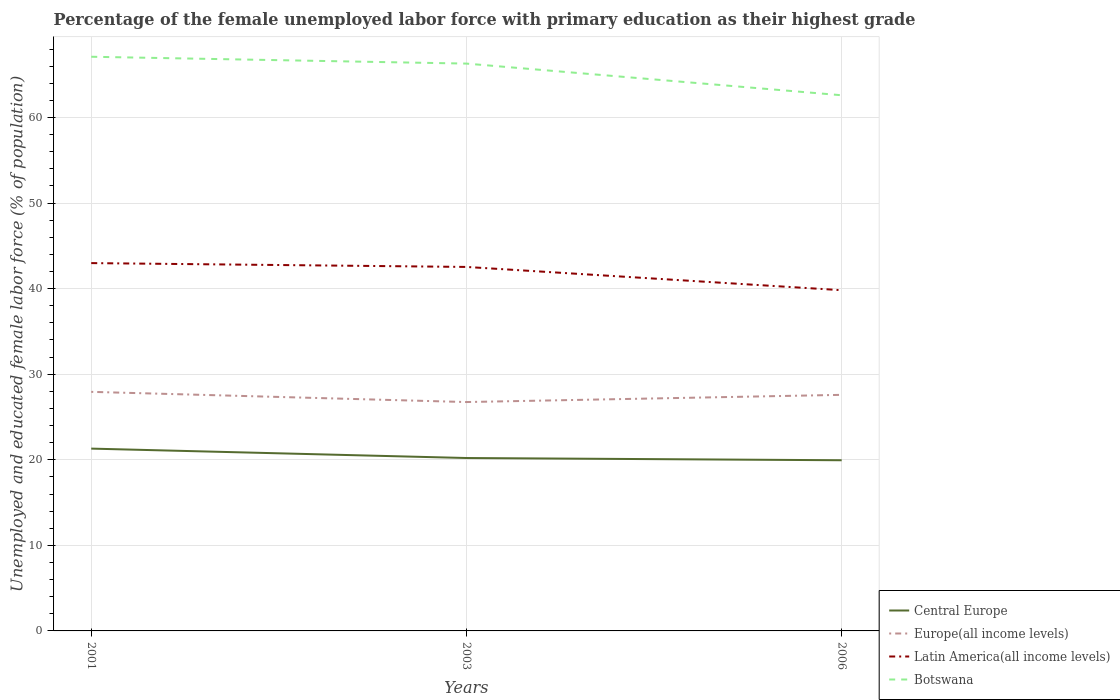Across all years, what is the maximum percentage of the unemployed female labor force with primary education in Botswana?
Your answer should be compact. 62.6. In which year was the percentage of the unemployed female labor force with primary education in Latin America(all income levels) maximum?
Make the answer very short. 2006. What is the total percentage of the unemployed female labor force with primary education in Latin America(all income levels) in the graph?
Your answer should be very brief. 0.45. What is the difference between the highest and the second highest percentage of the unemployed female labor force with primary education in Latin America(all income levels)?
Give a very brief answer. 3.17. What is the difference between the highest and the lowest percentage of the unemployed female labor force with primary education in Latin America(all income levels)?
Make the answer very short. 2. Is the percentage of the unemployed female labor force with primary education in Botswana strictly greater than the percentage of the unemployed female labor force with primary education in Latin America(all income levels) over the years?
Your answer should be very brief. No. How many lines are there?
Provide a short and direct response. 4. Does the graph contain any zero values?
Keep it short and to the point. No. Does the graph contain grids?
Your response must be concise. Yes. What is the title of the graph?
Ensure brevity in your answer.  Percentage of the female unemployed labor force with primary education as their highest grade. What is the label or title of the Y-axis?
Your answer should be very brief. Unemployed and educated female labor force (% of population). What is the Unemployed and educated female labor force (% of population) in Central Europe in 2001?
Offer a terse response. 21.31. What is the Unemployed and educated female labor force (% of population) of Europe(all income levels) in 2001?
Give a very brief answer. 27.94. What is the Unemployed and educated female labor force (% of population) of Latin America(all income levels) in 2001?
Ensure brevity in your answer.  42.99. What is the Unemployed and educated female labor force (% of population) of Botswana in 2001?
Keep it short and to the point. 67.1. What is the Unemployed and educated female labor force (% of population) in Central Europe in 2003?
Make the answer very short. 20.21. What is the Unemployed and educated female labor force (% of population) in Europe(all income levels) in 2003?
Offer a terse response. 26.75. What is the Unemployed and educated female labor force (% of population) in Latin America(all income levels) in 2003?
Offer a very short reply. 42.54. What is the Unemployed and educated female labor force (% of population) of Botswana in 2003?
Provide a succinct answer. 66.3. What is the Unemployed and educated female labor force (% of population) of Central Europe in 2006?
Keep it short and to the point. 19.95. What is the Unemployed and educated female labor force (% of population) in Europe(all income levels) in 2006?
Ensure brevity in your answer.  27.59. What is the Unemployed and educated female labor force (% of population) in Latin America(all income levels) in 2006?
Your answer should be very brief. 39.82. What is the Unemployed and educated female labor force (% of population) of Botswana in 2006?
Your answer should be very brief. 62.6. Across all years, what is the maximum Unemployed and educated female labor force (% of population) in Central Europe?
Your answer should be compact. 21.31. Across all years, what is the maximum Unemployed and educated female labor force (% of population) of Europe(all income levels)?
Your response must be concise. 27.94. Across all years, what is the maximum Unemployed and educated female labor force (% of population) in Latin America(all income levels)?
Give a very brief answer. 42.99. Across all years, what is the maximum Unemployed and educated female labor force (% of population) in Botswana?
Give a very brief answer. 67.1. Across all years, what is the minimum Unemployed and educated female labor force (% of population) in Central Europe?
Your answer should be compact. 19.95. Across all years, what is the minimum Unemployed and educated female labor force (% of population) in Europe(all income levels)?
Your answer should be compact. 26.75. Across all years, what is the minimum Unemployed and educated female labor force (% of population) of Latin America(all income levels)?
Your answer should be very brief. 39.82. Across all years, what is the minimum Unemployed and educated female labor force (% of population) of Botswana?
Provide a succinct answer. 62.6. What is the total Unemployed and educated female labor force (% of population) in Central Europe in the graph?
Make the answer very short. 61.46. What is the total Unemployed and educated female labor force (% of population) of Europe(all income levels) in the graph?
Ensure brevity in your answer.  82.27. What is the total Unemployed and educated female labor force (% of population) of Latin America(all income levels) in the graph?
Give a very brief answer. 125.34. What is the total Unemployed and educated female labor force (% of population) of Botswana in the graph?
Your answer should be compact. 196. What is the difference between the Unemployed and educated female labor force (% of population) of Europe(all income levels) in 2001 and that in 2003?
Provide a short and direct response. 1.19. What is the difference between the Unemployed and educated female labor force (% of population) in Latin America(all income levels) in 2001 and that in 2003?
Provide a short and direct response. 0.45. What is the difference between the Unemployed and educated female labor force (% of population) in Botswana in 2001 and that in 2003?
Offer a very short reply. 0.8. What is the difference between the Unemployed and educated female labor force (% of population) of Central Europe in 2001 and that in 2006?
Your answer should be very brief. 1.36. What is the difference between the Unemployed and educated female labor force (% of population) in Europe(all income levels) in 2001 and that in 2006?
Your answer should be compact. 0.35. What is the difference between the Unemployed and educated female labor force (% of population) of Latin America(all income levels) in 2001 and that in 2006?
Ensure brevity in your answer.  3.17. What is the difference between the Unemployed and educated female labor force (% of population) in Botswana in 2001 and that in 2006?
Ensure brevity in your answer.  4.5. What is the difference between the Unemployed and educated female labor force (% of population) of Central Europe in 2003 and that in 2006?
Your answer should be very brief. 0.26. What is the difference between the Unemployed and educated female labor force (% of population) of Europe(all income levels) in 2003 and that in 2006?
Offer a very short reply. -0.84. What is the difference between the Unemployed and educated female labor force (% of population) of Latin America(all income levels) in 2003 and that in 2006?
Offer a very short reply. 2.72. What is the difference between the Unemployed and educated female labor force (% of population) of Botswana in 2003 and that in 2006?
Ensure brevity in your answer.  3.7. What is the difference between the Unemployed and educated female labor force (% of population) of Central Europe in 2001 and the Unemployed and educated female labor force (% of population) of Europe(all income levels) in 2003?
Provide a succinct answer. -5.44. What is the difference between the Unemployed and educated female labor force (% of population) in Central Europe in 2001 and the Unemployed and educated female labor force (% of population) in Latin America(all income levels) in 2003?
Offer a very short reply. -21.23. What is the difference between the Unemployed and educated female labor force (% of population) of Central Europe in 2001 and the Unemployed and educated female labor force (% of population) of Botswana in 2003?
Your answer should be compact. -44.99. What is the difference between the Unemployed and educated female labor force (% of population) of Europe(all income levels) in 2001 and the Unemployed and educated female labor force (% of population) of Latin America(all income levels) in 2003?
Ensure brevity in your answer.  -14.6. What is the difference between the Unemployed and educated female labor force (% of population) of Europe(all income levels) in 2001 and the Unemployed and educated female labor force (% of population) of Botswana in 2003?
Provide a succinct answer. -38.36. What is the difference between the Unemployed and educated female labor force (% of population) in Latin America(all income levels) in 2001 and the Unemployed and educated female labor force (% of population) in Botswana in 2003?
Provide a succinct answer. -23.31. What is the difference between the Unemployed and educated female labor force (% of population) in Central Europe in 2001 and the Unemployed and educated female labor force (% of population) in Europe(all income levels) in 2006?
Offer a very short reply. -6.28. What is the difference between the Unemployed and educated female labor force (% of population) of Central Europe in 2001 and the Unemployed and educated female labor force (% of population) of Latin America(all income levels) in 2006?
Your response must be concise. -18.51. What is the difference between the Unemployed and educated female labor force (% of population) in Central Europe in 2001 and the Unemployed and educated female labor force (% of population) in Botswana in 2006?
Your response must be concise. -41.29. What is the difference between the Unemployed and educated female labor force (% of population) in Europe(all income levels) in 2001 and the Unemployed and educated female labor force (% of population) in Latin America(all income levels) in 2006?
Your answer should be compact. -11.88. What is the difference between the Unemployed and educated female labor force (% of population) in Europe(all income levels) in 2001 and the Unemployed and educated female labor force (% of population) in Botswana in 2006?
Make the answer very short. -34.66. What is the difference between the Unemployed and educated female labor force (% of population) of Latin America(all income levels) in 2001 and the Unemployed and educated female labor force (% of population) of Botswana in 2006?
Your answer should be compact. -19.61. What is the difference between the Unemployed and educated female labor force (% of population) in Central Europe in 2003 and the Unemployed and educated female labor force (% of population) in Europe(all income levels) in 2006?
Make the answer very short. -7.38. What is the difference between the Unemployed and educated female labor force (% of population) of Central Europe in 2003 and the Unemployed and educated female labor force (% of population) of Latin America(all income levels) in 2006?
Offer a very short reply. -19.61. What is the difference between the Unemployed and educated female labor force (% of population) of Central Europe in 2003 and the Unemployed and educated female labor force (% of population) of Botswana in 2006?
Ensure brevity in your answer.  -42.39. What is the difference between the Unemployed and educated female labor force (% of population) in Europe(all income levels) in 2003 and the Unemployed and educated female labor force (% of population) in Latin America(all income levels) in 2006?
Your response must be concise. -13.07. What is the difference between the Unemployed and educated female labor force (% of population) of Europe(all income levels) in 2003 and the Unemployed and educated female labor force (% of population) of Botswana in 2006?
Your answer should be very brief. -35.85. What is the difference between the Unemployed and educated female labor force (% of population) in Latin America(all income levels) in 2003 and the Unemployed and educated female labor force (% of population) in Botswana in 2006?
Your answer should be very brief. -20.06. What is the average Unemployed and educated female labor force (% of population) in Central Europe per year?
Your response must be concise. 20.49. What is the average Unemployed and educated female labor force (% of population) in Europe(all income levels) per year?
Keep it short and to the point. 27.42. What is the average Unemployed and educated female labor force (% of population) of Latin America(all income levels) per year?
Keep it short and to the point. 41.78. What is the average Unemployed and educated female labor force (% of population) in Botswana per year?
Provide a succinct answer. 65.33. In the year 2001, what is the difference between the Unemployed and educated female labor force (% of population) in Central Europe and Unemployed and educated female labor force (% of population) in Europe(all income levels)?
Ensure brevity in your answer.  -6.63. In the year 2001, what is the difference between the Unemployed and educated female labor force (% of population) in Central Europe and Unemployed and educated female labor force (% of population) in Latin America(all income levels)?
Keep it short and to the point. -21.68. In the year 2001, what is the difference between the Unemployed and educated female labor force (% of population) of Central Europe and Unemployed and educated female labor force (% of population) of Botswana?
Your response must be concise. -45.79. In the year 2001, what is the difference between the Unemployed and educated female labor force (% of population) in Europe(all income levels) and Unemployed and educated female labor force (% of population) in Latin America(all income levels)?
Your answer should be very brief. -15.05. In the year 2001, what is the difference between the Unemployed and educated female labor force (% of population) of Europe(all income levels) and Unemployed and educated female labor force (% of population) of Botswana?
Your answer should be compact. -39.16. In the year 2001, what is the difference between the Unemployed and educated female labor force (% of population) of Latin America(all income levels) and Unemployed and educated female labor force (% of population) of Botswana?
Your response must be concise. -24.11. In the year 2003, what is the difference between the Unemployed and educated female labor force (% of population) of Central Europe and Unemployed and educated female labor force (% of population) of Europe(all income levels)?
Offer a very short reply. -6.54. In the year 2003, what is the difference between the Unemployed and educated female labor force (% of population) of Central Europe and Unemployed and educated female labor force (% of population) of Latin America(all income levels)?
Offer a very short reply. -22.33. In the year 2003, what is the difference between the Unemployed and educated female labor force (% of population) of Central Europe and Unemployed and educated female labor force (% of population) of Botswana?
Provide a succinct answer. -46.09. In the year 2003, what is the difference between the Unemployed and educated female labor force (% of population) of Europe(all income levels) and Unemployed and educated female labor force (% of population) of Latin America(all income levels)?
Your response must be concise. -15.79. In the year 2003, what is the difference between the Unemployed and educated female labor force (% of population) in Europe(all income levels) and Unemployed and educated female labor force (% of population) in Botswana?
Give a very brief answer. -39.55. In the year 2003, what is the difference between the Unemployed and educated female labor force (% of population) in Latin America(all income levels) and Unemployed and educated female labor force (% of population) in Botswana?
Your response must be concise. -23.76. In the year 2006, what is the difference between the Unemployed and educated female labor force (% of population) of Central Europe and Unemployed and educated female labor force (% of population) of Europe(all income levels)?
Offer a terse response. -7.64. In the year 2006, what is the difference between the Unemployed and educated female labor force (% of population) of Central Europe and Unemployed and educated female labor force (% of population) of Latin America(all income levels)?
Ensure brevity in your answer.  -19.87. In the year 2006, what is the difference between the Unemployed and educated female labor force (% of population) in Central Europe and Unemployed and educated female labor force (% of population) in Botswana?
Your answer should be compact. -42.65. In the year 2006, what is the difference between the Unemployed and educated female labor force (% of population) of Europe(all income levels) and Unemployed and educated female labor force (% of population) of Latin America(all income levels)?
Provide a succinct answer. -12.23. In the year 2006, what is the difference between the Unemployed and educated female labor force (% of population) in Europe(all income levels) and Unemployed and educated female labor force (% of population) in Botswana?
Provide a short and direct response. -35.01. In the year 2006, what is the difference between the Unemployed and educated female labor force (% of population) of Latin America(all income levels) and Unemployed and educated female labor force (% of population) of Botswana?
Your answer should be compact. -22.78. What is the ratio of the Unemployed and educated female labor force (% of population) in Central Europe in 2001 to that in 2003?
Ensure brevity in your answer.  1.05. What is the ratio of the Unemployed and educated female labor force (% of population) in Europe(all income levels) in 2001 to that in 2003?
Provide a short and direct response. 1.04. What is the ratio of the Unemployed and educated female labor force (% of population) of Latin America(all income levels) in 2001 to that in 2003?
Your answer should be compact. 1.01. What is the ratio of the Unemployed and educated female labor force (% of population) of Botswana in 2001 to that in 2003?
Provide a short and direct response. 1.01. What is the ratio of the Unemployed and educated female labor force (% of population) in Central Europe in 2001 to that in 2006?
Offer a terse response. 1.07. What is the ratio of the Unemployed and educated female labor force (% of population) in Europe(all income levels) in 2001 to that in 2006?
Your answer should be very brief. 1.01. What is the ratio of the Unemployed and educated female labor force (% of population) of Latin America(all income levels) in 2001 to that in 2006?
Make the answer very short. 1.08. What is the ratio of the Unemployed and educated female labor force (% of population) of Botswana in 2001 to that in 2006?
Provide a succinct answer. 1.07. What is the ratio of the Unemployed and educated female labor force (% of population) in Central Europe in 2003 to that in 2006?
Your answer should be compact. 1.01. What is the ratio of the Unemployed and educated female labor force (% of population) in Europe(all income levels) in 2003 to that in 2006?
Your answer should be compact. 0.97. What is the ratio of the Unemployed and educated female labor force (% of population) of Latin America(all income levels) in 2003 to that in 2006?
Your response must be concise. 1.07. What is the ratio of the Unemployed and educated female labor force (% of population) of Botswana in 2003 to that in 2006?
Offer a very short reply. 1.06. What is the difference between the highest and the second highest Unemployed and educated female labor force (% of population) of Europe(all income levels)?
Keep it short and to the point. 0.35. What is the difference between the highest and the second highest Unemployed and educated female labor force (% of population) in Latin America(all income levels)?
Your answer should be compact. 0.45. What is the difference between the highest and the second highest Unemployed and educated female labor force (% of population) of Botswana?
Offer a very short reply. 0.8. What is the difference between the highest and the lowest Unemployed and educated female labor force (% of population) of Central Europe?
Offer a terse response. 1.36. What is the difference between the highest and the lowest Unemployed and educated female labor force (% of population) in Europe(all income levels)?
Your answer should be very brief. 1.19. What is the difference between the highest and the lowest Unemployed and educated female labor force (% of population) in Latin America(all income levels)?
Your response must be concise. 3.17. 